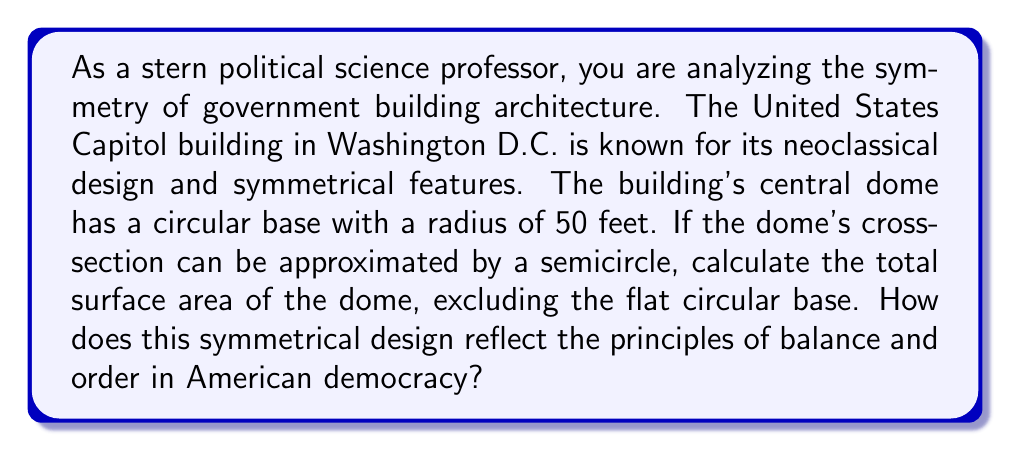Give your solution to this math problem. To solve this problem, we need to calculate the surface area of a hemisphere, which represents the dome of the Capitol building. The formula for the surface area of a hemisphere is:

$$A = 2\pi r^2$$

Where:
$A$ is the surface area
$r$ is the radius of the base

Given:
$r = 50$ feet

Step 1: Substitute the given radius into the formula.
$$A = 2\pi (50)^2$$

Step 2: Simplify the expression.
$$A = 2\pi (2500)$$
$$A = 5000\pi$$

Step 3: Calculate the final result.
$$A \approx 15,707.96 \text{ square feet}$$

This symmetrical design of the Capitol dome reflects the principles of balance and order in American democracy in several ways:

1. Equality: The perfect semicircle represents equal representation from all angles, symbolizing the equal voice of all citizens in a democracy.

2. Unity: The circular base and symmetrical dome suggest a unified nation, with power emanating equally from a central point.

3. Stability: The balanced structure of the dome implies a stable and enduring system of government.

4. Transparency: The dome's visibility from all sides can be seen as a metaphor for government transparency and accountability.

5. Rationality: The use of geometric forms in neoclassical architecture reflects the Enlightenment ideals of reason and logic that influenced the Founding Fathers.
Answer: The surface area of the Capitol dome, excluding the base, is approximately 15,707.96 square feet. This symmetrical design reflects democratic principles through its representation of equality, unity, stability, transparency, and rationality in architectural form. 